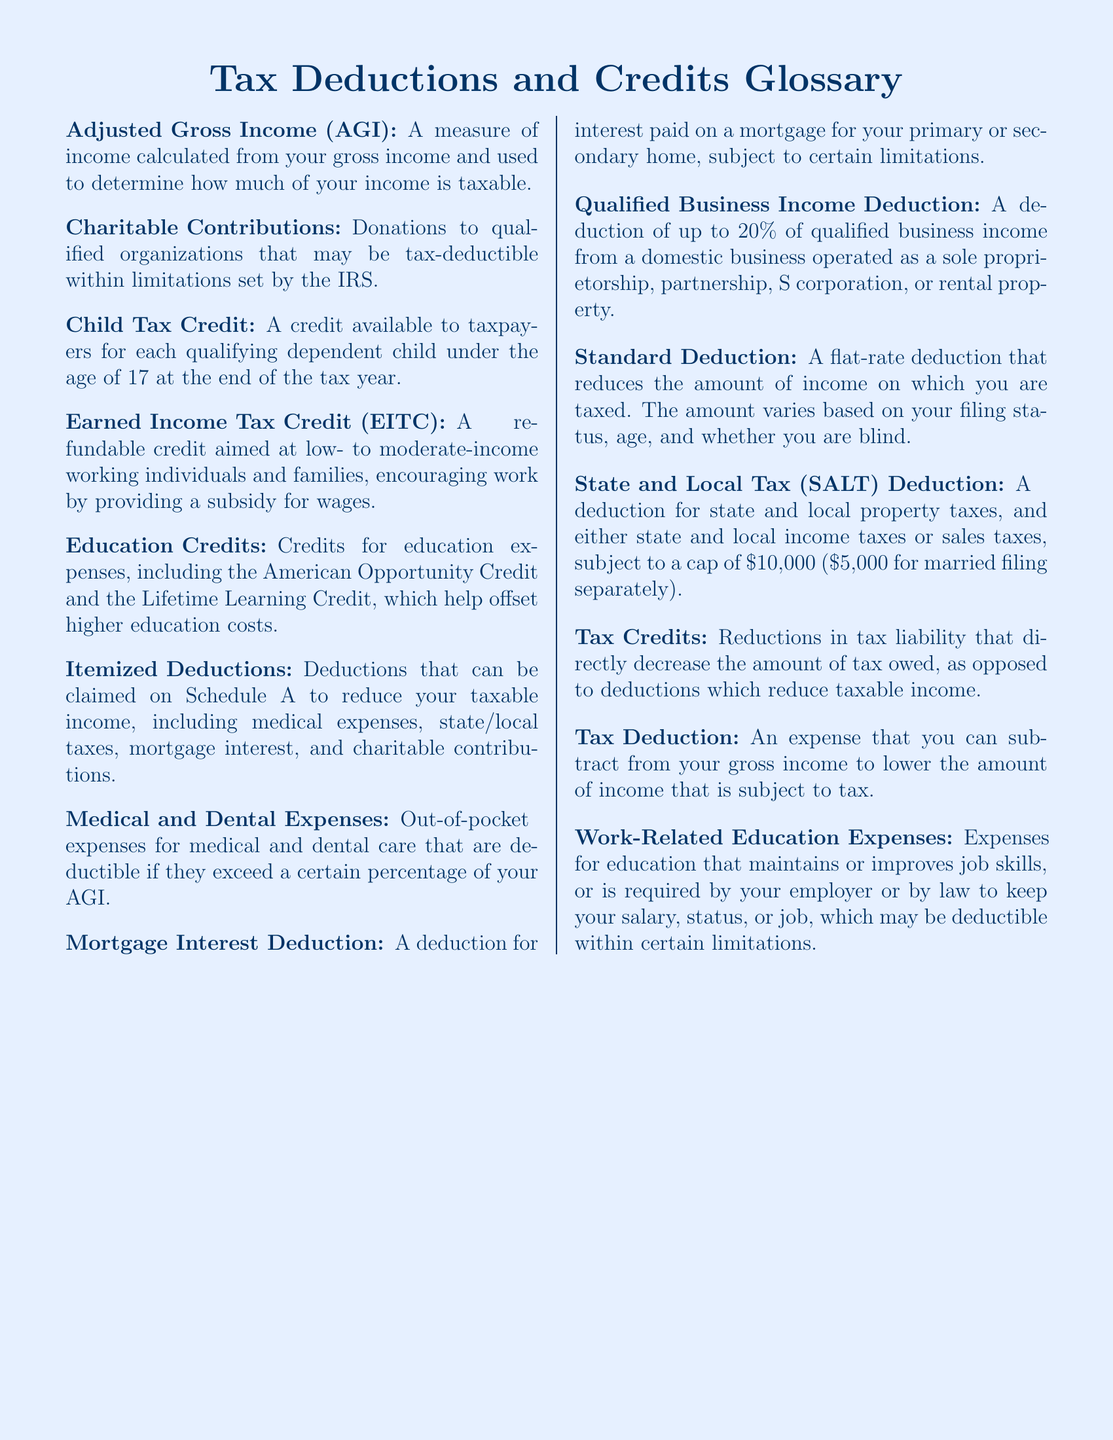What is the measure of income used to determine taxable income? Adjusted Gross Income (AGI) is calculated from gross income to determine taxable income.
Answer: Adjusted Gross Income (AGI) What is the maximum percentage for the Qualified Business Income Deduction? The deduction allows a claim of up to 20% of qualified business income.
Answer: 20% Which credit is available for each qualifying dependent child under the age of 17? This credit is known as the Child Tax Credit, applicable for eligible dependent children under 17 years old.
Answer: Child Tax Credit What is the standard cap on the State and Local Tax (SALT) Deduction? The SALT deduction is subject to a cap of $10,000 for most filers.
Answer: $10,000 What type of expenses can be deducted as Medical and Dental Expenses? Out-of-pocket medical and dental care expenses that exceed a certain percentage of AGI can be deducted.
Answer: Out-of-pocket medical and dental care expenses What do Tax Credits do to your tax liability? Tax Credits directly decrease the amount of tax owed compared to deductions which reduce taxable income.
Answer: Directly decrease Which deduction can you use if you do not itemize your deductions? The Standard Deduction is available for taxpayers who do not itemize.
Answer: Standard Deduction What expenses may be deductible for Work-Related Education? Expenses maintaining or improving job skills required by the employer or law may be deductible.
Answer: Education expenses What is the focus of the Earned Income Tax Credit (EITC)? The EITC is aimed at low- to moderate-income working individuals and families.
Answer: Low- to moderate-income working individuals and families What is included in Itemized Deductions? Itemized deductions can include medical expenses, taxes, mortgage interest, and charitable contributions.
Answer: Medical expenses, state/local taxes, mortgage interest, charitable contributions 